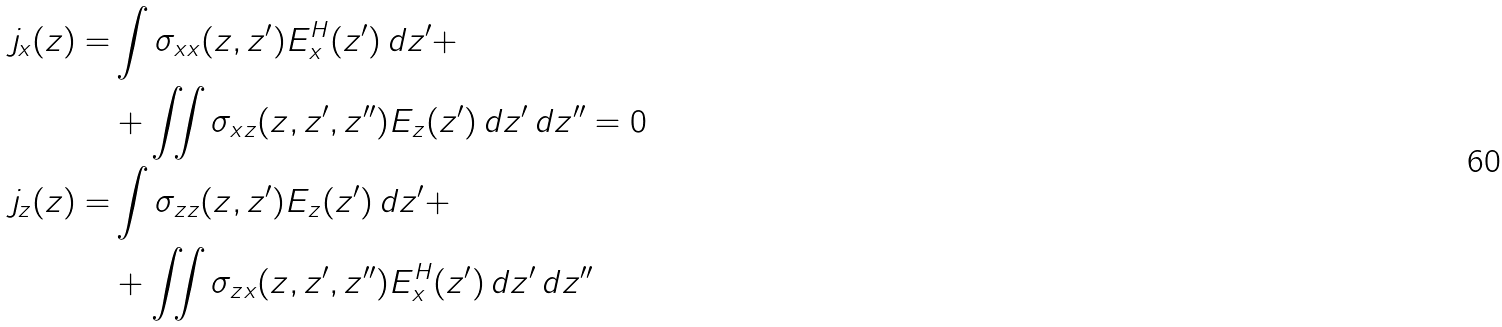<formula> <loc_0><loc_0><loc_500><loc_500>j _ { x } ( z ) = & \int \sigma _ { x x } ( z , z ^ { \prime } ) E _ { x } ^ { H } ( z ^ { \prime } ) \, d z ^ { \prime } + \\ & + \iint \sigma _ { x z } ( z , z ^ { \prime } , z ^ { \prime \prime } ) E _ { z } ( z ^ { \prime } ) \, d z ^ { \prime } \, d z ^ { \prime \prime } = 0 \\ j _ { z } ( z ) = & \int \sigma _ { z z } ( z , z ^ { \prime } ) E _ { z } ( z ^ { \prime } ) \, d z ^ { \prime } + \\ & + \iint \sigma _ { z x } ( z , z ^ { \prime } , z ^ { \prime \prime } ) E _ { x } ^ { H } ( z ^ { \prime } ) \, d z ^ { \prime } \, d z ^ { \prime \prime }</formula> 